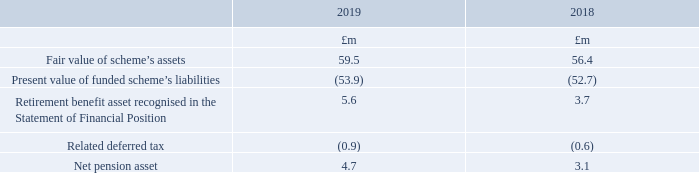£1.5m (2018: £1.4m) of scheme assets have a quoted market price in an active market.
The actual return on plan assets was a gain of £5.5m (2018: £1.0m loss).
The amounts recognised in the Company Statement of Financial Position are determined as follows:
What is the Fair value of scheme’s assets at 2019?
Answer scale should be: million. 59.5. What was the actual return on plan assets? A gain of £5.5m (2018: £1.0m loss). For which years was the net pension asset calculated for? 2019, 2018. In which year was the net pension asset larger? 4.7>3.1
Answer: 2019. What was the change in net pension asset from 2018 to 2019?
Answer scale should be: million. 4.7-3.1
Answer: 1.6. What was the percentage change in net pension asset from 2018 to 2019?
Answer scale should be: percent. (4.7-3.1)/3.1
Answer: 51.61. 